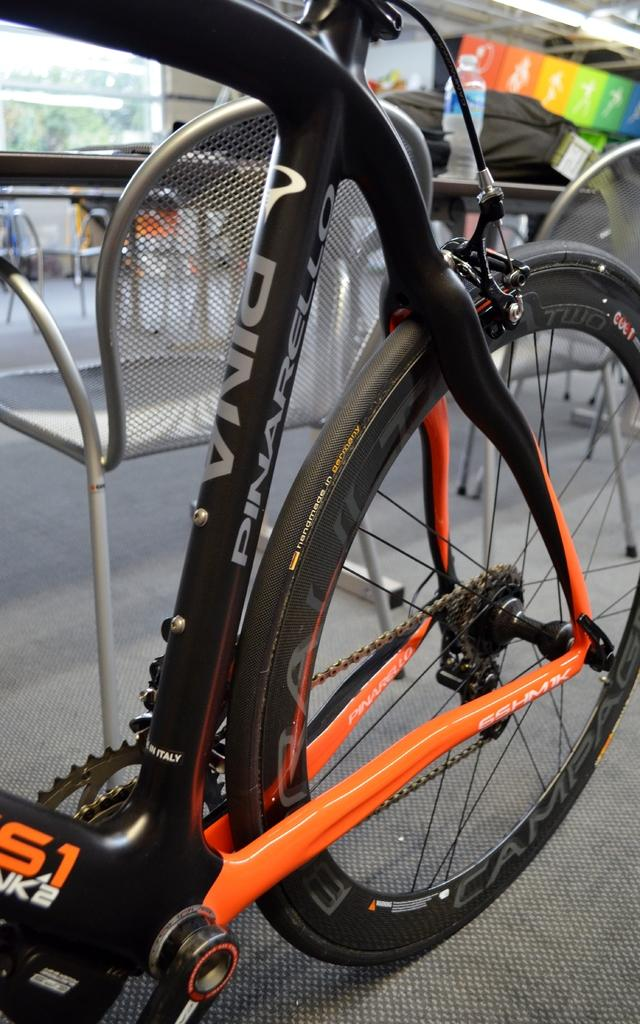What is the main subject of the image? The main subject of the image is a bicycle on the floor. What can be seen in the background of the image? There are chairs and a table in the background of the image. What is the bicycle accessory visible in the image? A water bottle is visible in the image. What type of bag is present in the image? There is a black color bag in the image. What type of pencil can be seen in the image? There is no pencil present in the image. Is the alley visible in the image? The image does not show an alley; it is a zoomed-in picture of a bicycle on the floor. 